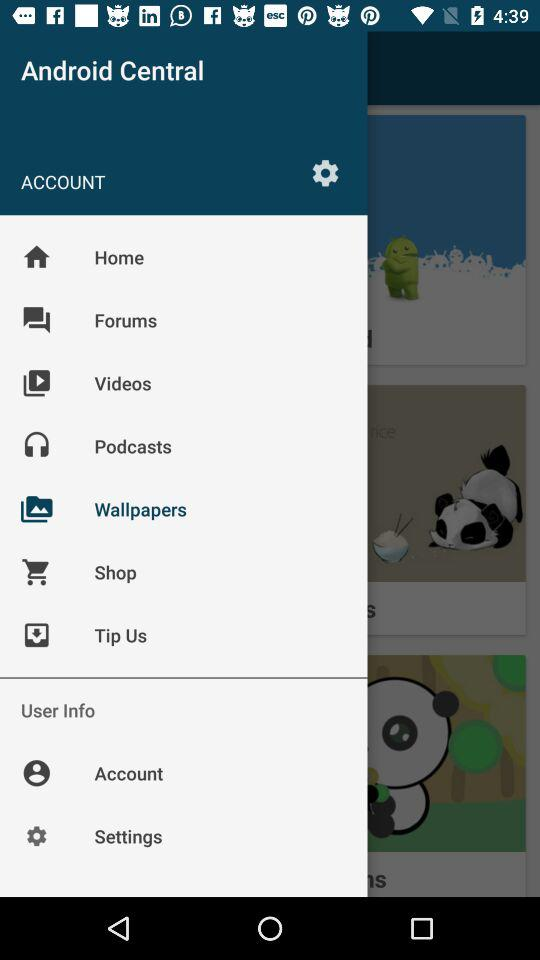What is the application name? The application name is "Android Central". 